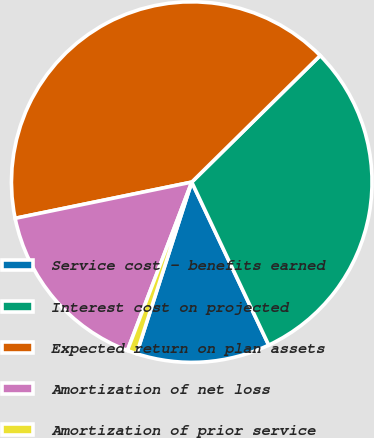<chart> <loc_0><loc_0><loc_500><loc_500><pie_chart><fcel>Service cost - benefits earned<fcel>Interest cost on projected<fcel>Expected return on plan assets<fcel>Amortization of net loss<fcel>Amortization of prior service<nl><fcel>11.97%<fcel>30.36%<fcel>40.84%<fcel>15.97%<fcel>0.86%<nl></chart> 